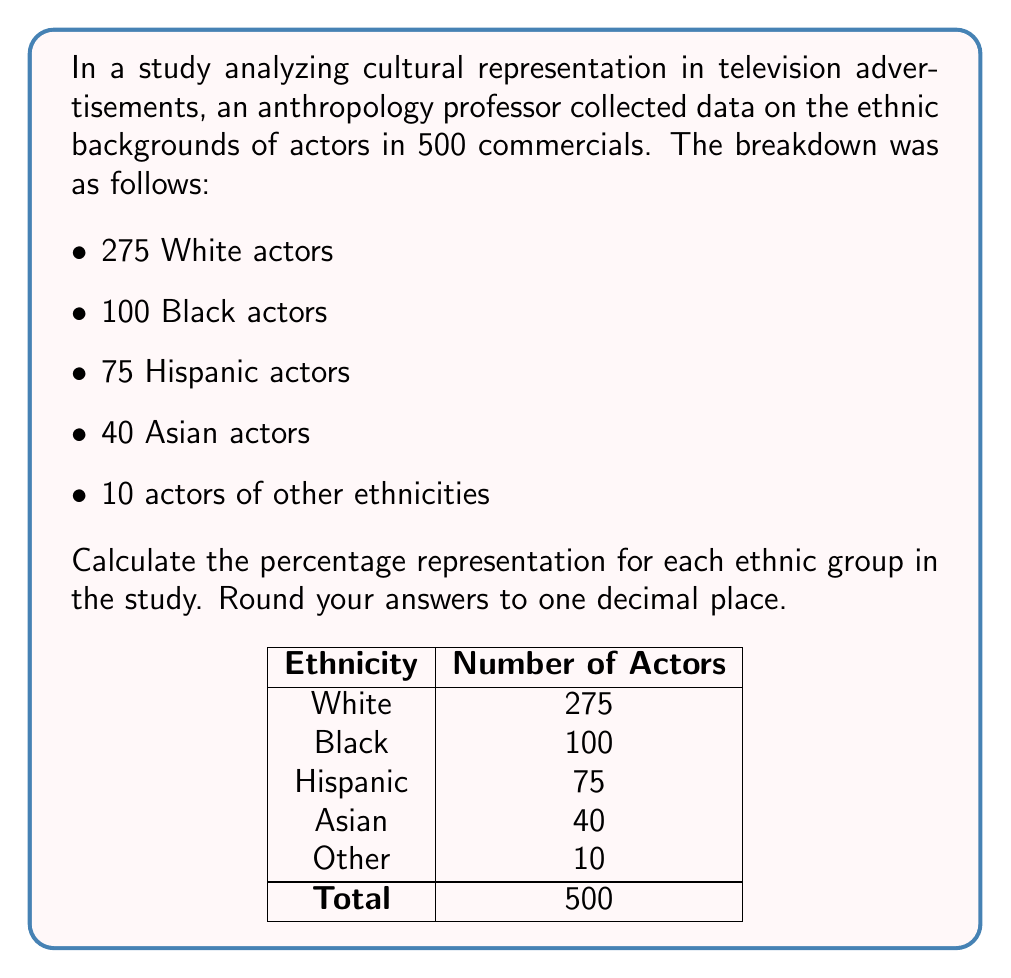Provide a solution to this math problem. To calculate the percentage representation for each ethnic group, we need to follow these steps:

1. Calculate the total number of actors:
   $275 + 100 + 75 + 40 + 10 = 500$ total actors

2. For each ethnic group, use the formula:
   $\text{Percentage} = \frac{\text{Number in group}}{\text{Total number}} \times 100\%$

3. Calculate for each group:

   White: 
   $$\frac{275}{500} \times 100\% = 55\%$$

   Black: 
   $$\frac{100}{500} \times 100\% = 20\%$$

   Hispanic: 
   $$\frac{75}{500} \times 100\% = 15\%$$

   Asian: 
   $$\frac{40}{500} \times 100\% = 8\%$$

   Other: 
   $$\frac{10}{500} \times 100\% = 2\%$$

4. Round each result to one decimal place.

These percentages provide insight into the cultural representation in advertising, which is crucial for anthropological analysis of media representation.
Answer: White: 55.0%, Black: 20.0%, Hispanic: 15.0%, Asian: 8.0%, Other: 2.0% 